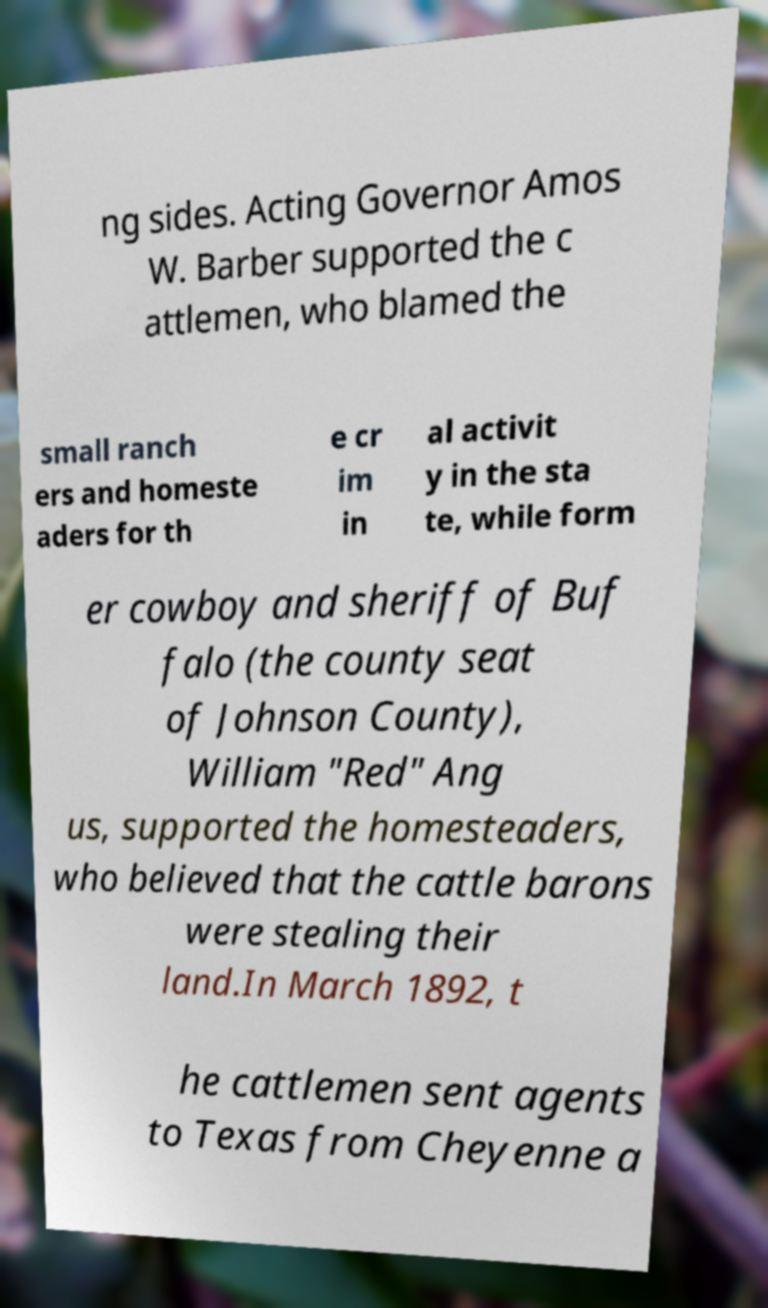Please identify and transcribe the text found in this image. ng sides. Acting Governor Amos W. Barber supported the c attlemen, who blamed the small ranch ers and homeste aders for th e cr im in al activit y in the sta te, while form er cowboy and sheriff of Buf falo (the county seat of Johnson County), William "Red" Ang us, supported the homesteaders, who believed that the cattle barons were stealing their land.In March 1892, t he cattlemen sent agents to Texas from Cheyenne a 